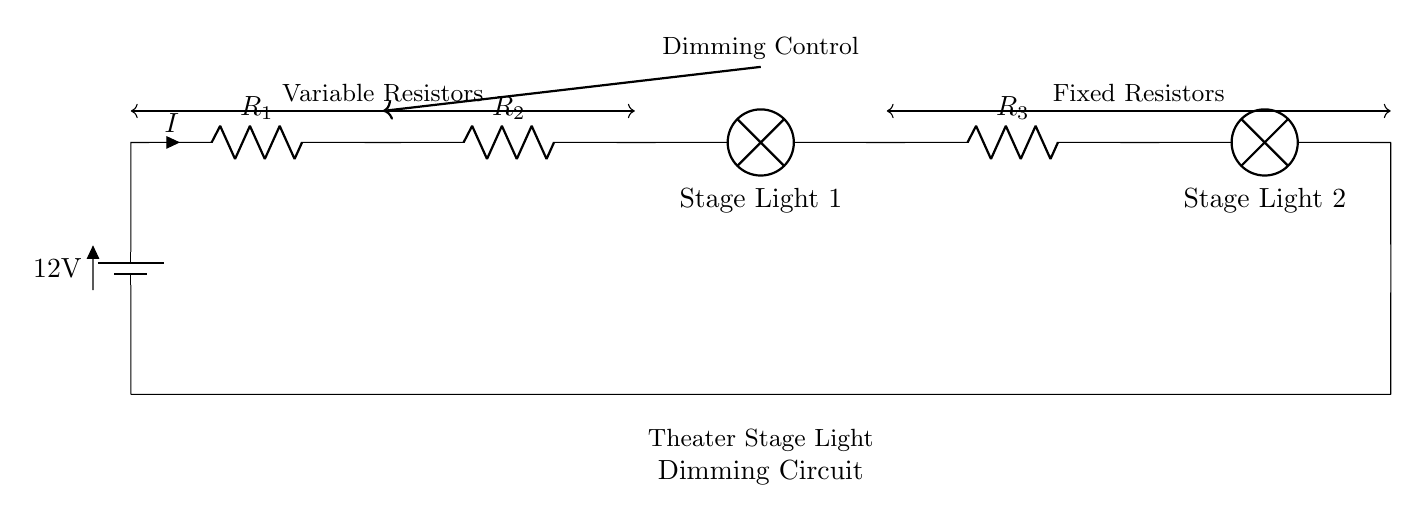What does the circuit primarily control? The circuit primarily controls the brightness of the stage lights by adjusting the resistance that affects the current flowing through them.
Answer: brightness What type of circuit is this? This is a series circuit, where components are connected one after another, and the current is the same through all components.
Answer: series How many resistors are in the circuit? There are three resistors shown in the circuit, specifically denoted as R1, R2, and R3.
Answer: three What is the voltage of the battery? The battery voltage is given as 12 volts, which is the initial voltage supplied to the circuit.
Answer: 12 volts What happens to the current if R1 is increased? If R1 is increased, the total resistance in the circuit increases, leading to a decrease in overall current according to Ohm's Law.
Answer: decreases Which elements in the circuit are variable? The circuit includes variable resistors, specifically the resistors used for dimming control, denoted from the left up to R2.
Answer: variable resistors What is the role of the fixed resistors in the circuit? The fixed resistors, such as R3, are used to set a constant amount of resistance, ensuring stable operation for certain portions of the circuit while dimming.
Answer: set constant resistance 